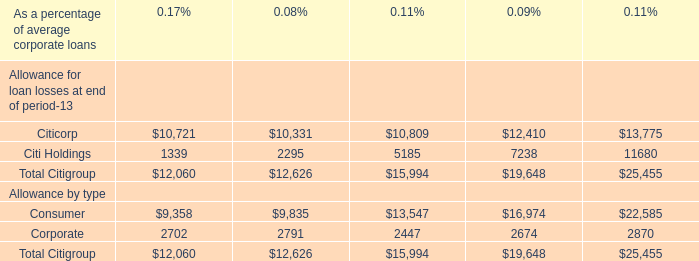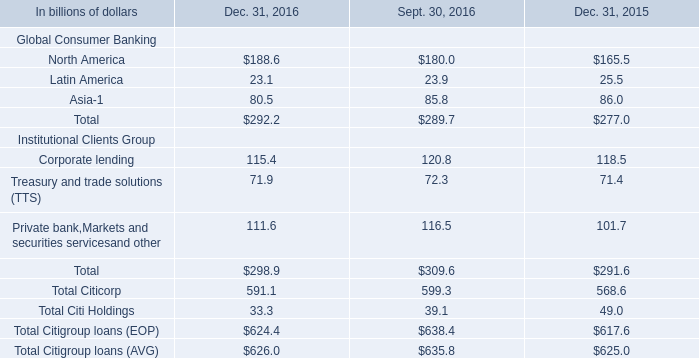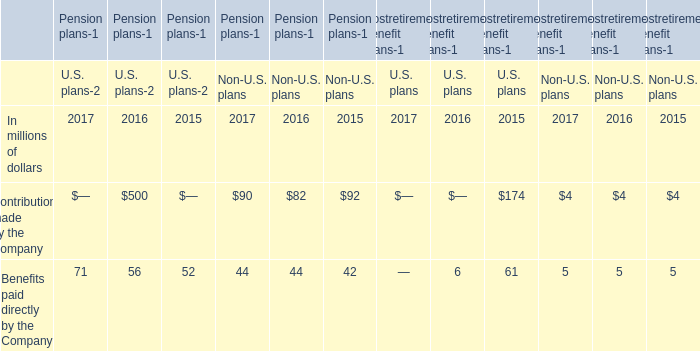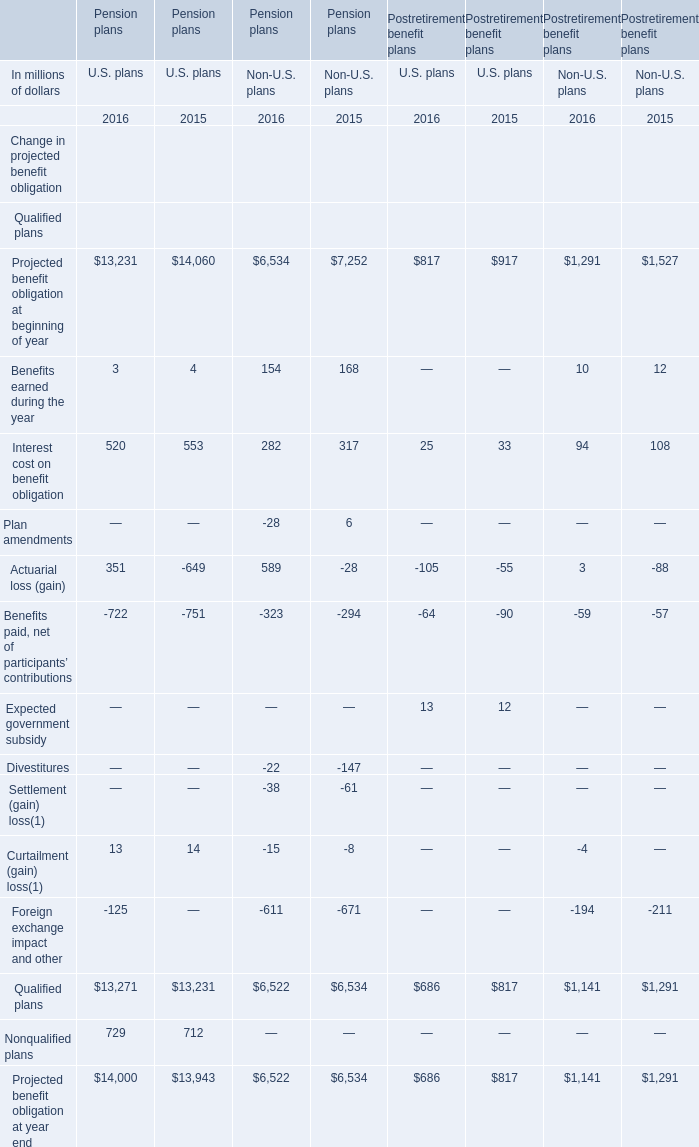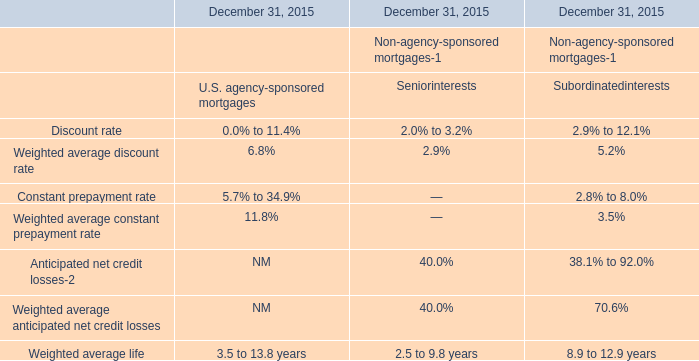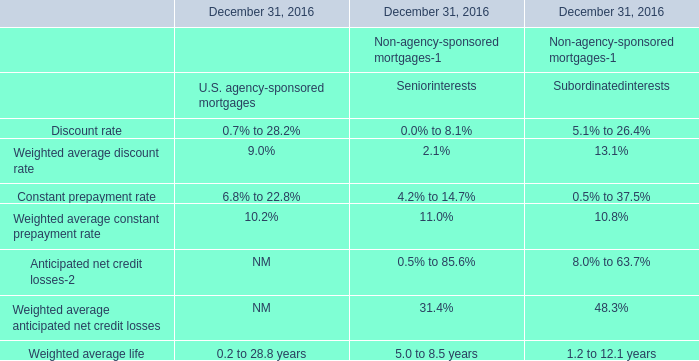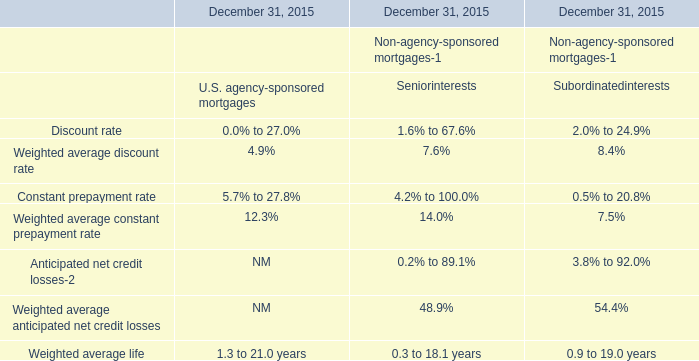What is the growing rate of Contributions made by the Company in the years with the least Benefits paid directly by the Company? 
Computations: ((((500 + 82) + 4) - ((92 + 174) + 4)) / ((92 + 174) + 4))
Answer: 1.17037. 